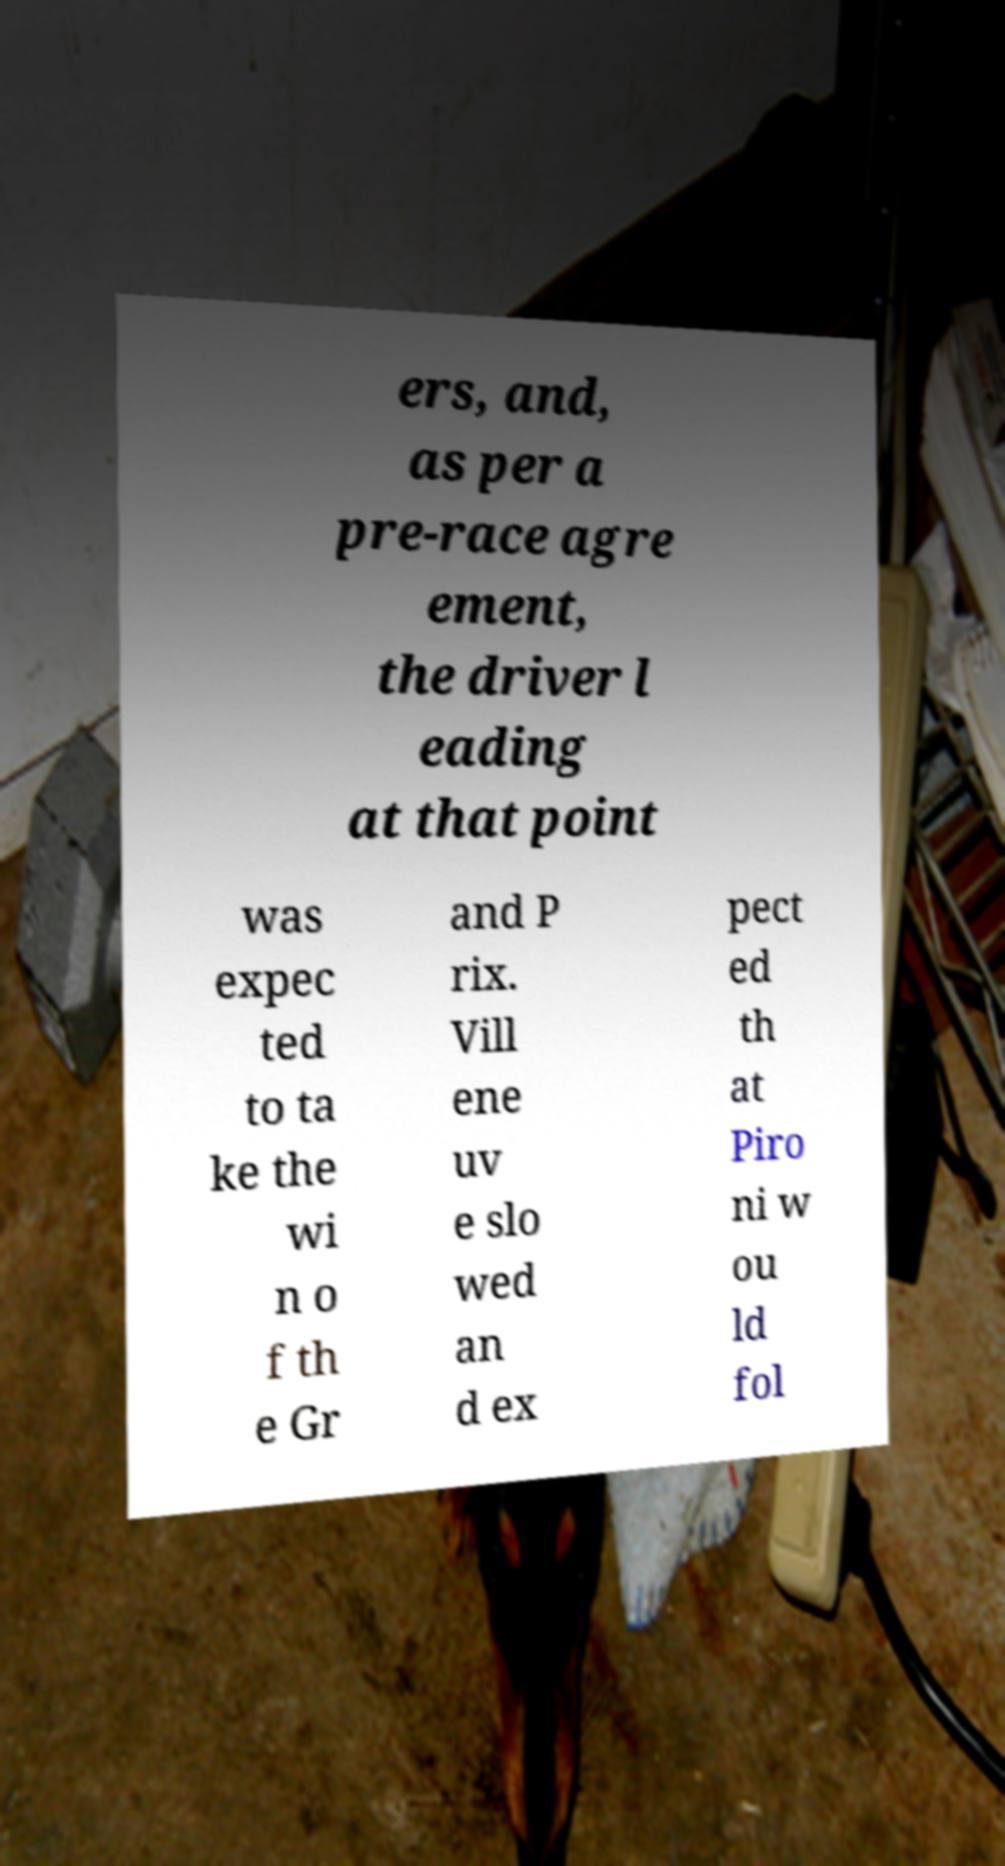What messages or text are displayed in this image? I need them in a readable, typed format. ers, and, as per a pre-race agre ement, the driver l eading at that point was expec ted to ta ke the wi n o f th e Gr and P rix. Vill ene uv e slo wed an d ex pect ed th at Piro ni w ou ld fol 